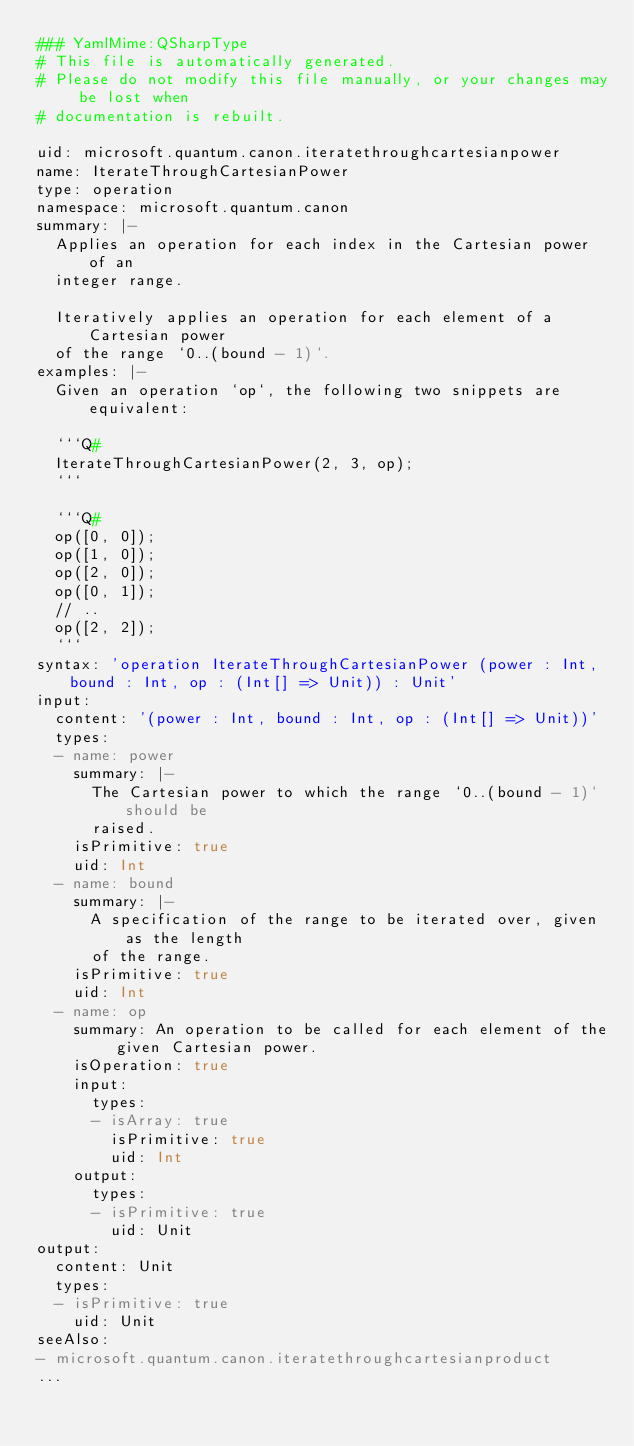Convert code to text. <code><loc_0><loc_0><loc_500><loc_500><_YAML_>### YamlMime:QSharpType
# This file is automatically generated.
# Please do not modify this file manually, or your changes may be lost when
# documentation is rebuilt.

uid: microsoft.quantum.canon.iteratethroughcartesianpower
name: IterateThroughCartesianPower
type: operation
namespace: microsoft.quantum.canon
summary: |-
  Applies an operation for each index in the Cartesian power of an
  integer range.

  Iteratively applies an operation for each element of a Cartesian power
  of the range `0..(bound - 1)`.
examples: |-
  Given an operation `op`, the following two snippets are equivalent:

  ```Q#
  IterateThroughCartesianPower(2, 3, op);
  ```

  ```Q#
  op([0, 0]);
  op([1, 0]);
  op([2, 0]);
  op([0, 1]);
  // ..
  op([2, 2]);
  ```
syntax: 'operation IterateThroughCartesianPower (power : Int, bound : Int, op : (Int[] => Unit)) : Unit'
input:
  content: '(power : Int, bound : Int, op : (Int[] => Unit))'
  types:
  - name: power
    summary: |-
      The Cartesian power to which the range `0..(bound - 1)` should be
      raised.
    isPrimitive: true
    uid: Int
  - name: bound
    summary: |-
      A specification of the range to be iterated over, given as the length
      of the range.
    isPrimitive: true
    uid: Int
  - name: op
    summary: An operation to be called for each element of the given Cartesian power.
    isOperation: true
    input:
      types:
      - isArray: true
        isPrimitive: true
        uid: Int
    output:
      types:
      - isPrimitive: true
        uid: Unit
output:
  content: Unit
  types:
  - isPrimitive: true
    uid: Unit
seeAlso:
- microsoft.quantum.canon.iteratethroughcartesianproduct
...
</code> 